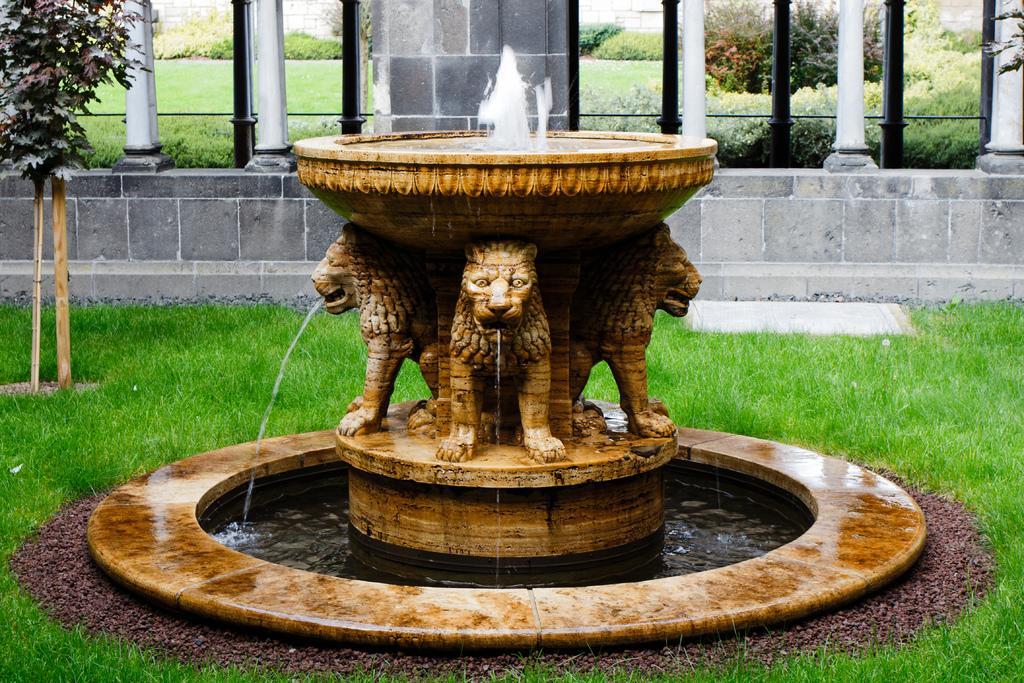In one or two sentences, can you explain what this image depicts? In this image, we can see some grass on the ground. There is a fountain in the middle of the image. There are pillars at the top of the image. There is a plant in the top left of the image. 